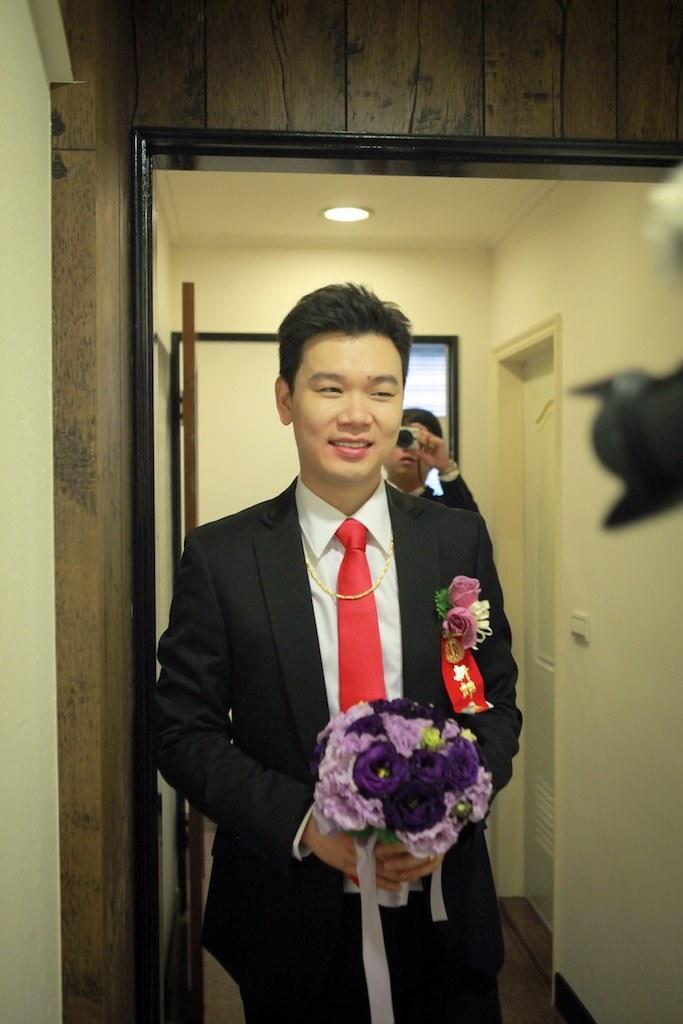Could you give a brief overview of what you see in this image? This picture seems to be clicked inside the room. In the foreground we can see a man wearing suit, smiling, holding a bouquet and seems to be standing. On the right corner we can see a black color object which seems to be the camera. In the background we can see the wall, roof, ceiling lights, doors and the window and we can see a person standing and holding some object. 